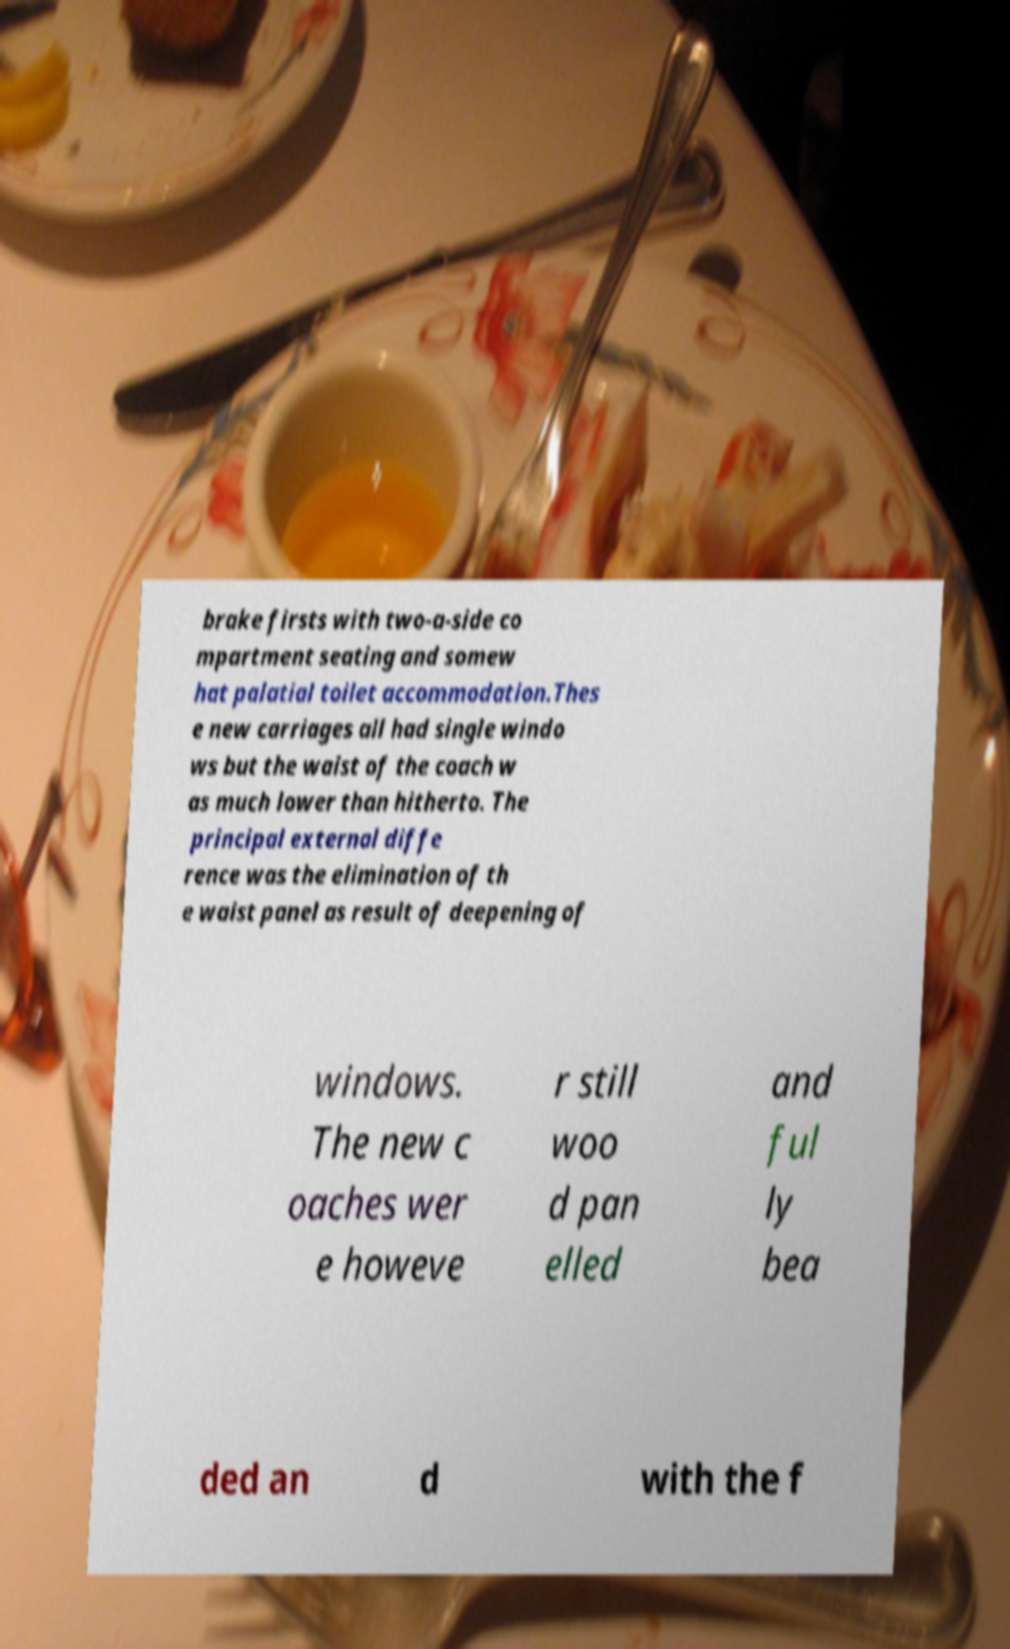There's text embedded in this image that I need extracted. Can you transcribe it verbatim? brake firsts with two-a-side co mpartment seating and somew hat palatial toilet accommodation.Thes e new carriages all had single windo ws but the waist of the coach w as much lower than hitherto. The principal external diffe rence was the elimination of th e waist panel as result of deepening of windows. The new c oaches wer e howeve r still woo d pan elled and ful ly bea ded an d with the f 